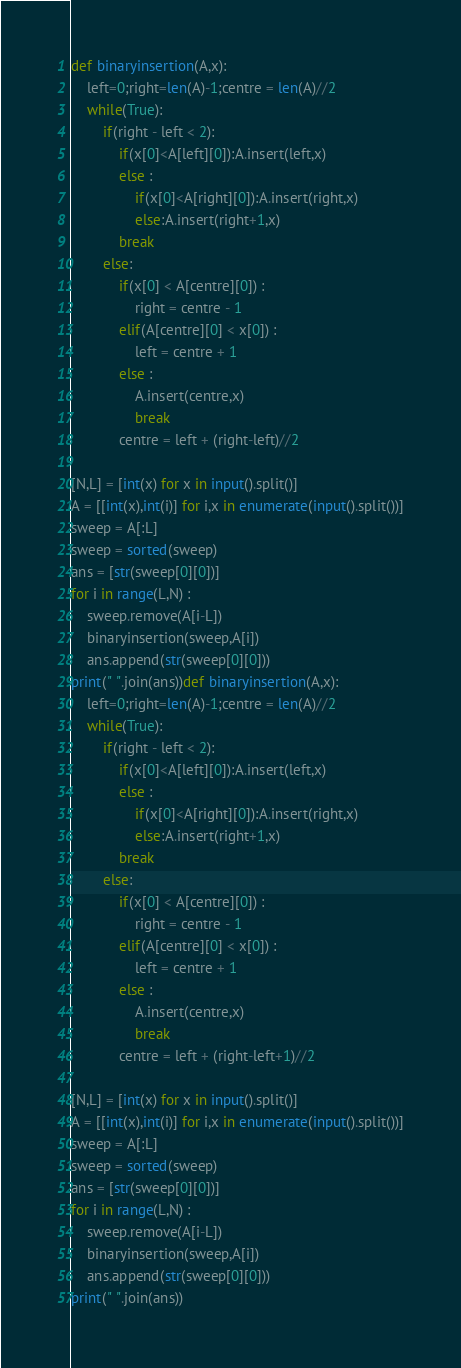Convert code to text. <code><loc_0><loc_0><loc_500><loc_500><_Python_>def binaryinsertion(A,x):
    left=0;right=len(A)-1;centre = len(A)//2
    while(True):
        if(right - left < 2):
            if(x[0]<A[left][0]):A.insert(left,x)
            else :
                if(x[0]<A[right][0]):A.insert(right,x)
                else:A.insert(right+1,x)
            break
        else:
            if(x[0] < A[centre][0]) :
                right = centre - 1
            elif(A[centre][0] < x[0]) :
                left = centre + 1
            else : 
                A.insert(centre,x)
                break
            centre = left + (right-left)//2

[N,L] = [int(x) for x in input().split()]
A = [[int(x),int(i)] for i,x in enumerate(input().split())]
sweep = A[:L]
sweep = sorted(sweep)
ans = [str(sweep[0][0])]
for i in range(L,N) :
    sweep.remove(A[i-L])
    binaryinsertion(sweep,A[i])
    ans.append(str(sweep[0][0]))
print(" ".join(ans))def binaryinsertion(A,x):
    left=0;right=len(A)-1;centre = len(A)//2
    while(True):
        if(right - left < 2):
            if(x[0]<A[left][0]):A.insert(left,x)
            else :
                if(x[0]<A[right][0]):A.insert(right,x)
                else:A.insert(right+1,x)
            break
        else:
            if(x[0] < A[centre][0]) :
                right = centre - 1
            elif(A[centre][0] < x[0]) :
                left = centre + 1
            else : 
                A.insert(centre,x)
                break
            centre = left + (right-left+1)//2

[N,L] = [int(x) for x in input().split()]
A = [[int(x),int(i)] for i,x in enumerate(input().split())]
sweep = A[:L]
sweep = sorted(sweep)
ans = [str(sweep[0][0])]
for i in range(L,N) :
    sweep.remove(A[i-L])
    binaryinsertion(sweep,A[i])
    ans.append(str(sweep[0][0]))
print(" ".join(ans))</code> 